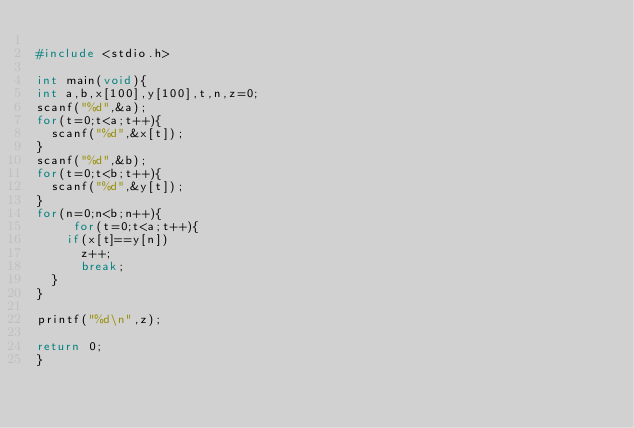Convert code to text. <code><loc_0><loc_0><loc_500><loc_500><_C_>
#include <stdio.h>

int main(void){
int a,b,x[100],y[100],t,n,z=0;
scanf("%d",&a);
for(t=0;t<a;t++){
	scanf("%d",&x[t]);
}
scanf("%d",&b);
for(t=0;t<b;t++){
	scanf("%d",&y[t]);
}
for(n=0;n<b;n++){
     for(t=0;t<a;t++){
		if(x[t]==y[n])
			z++;
			break;
	}
}

printf("%d\n",z);

return 0;
}</code> 